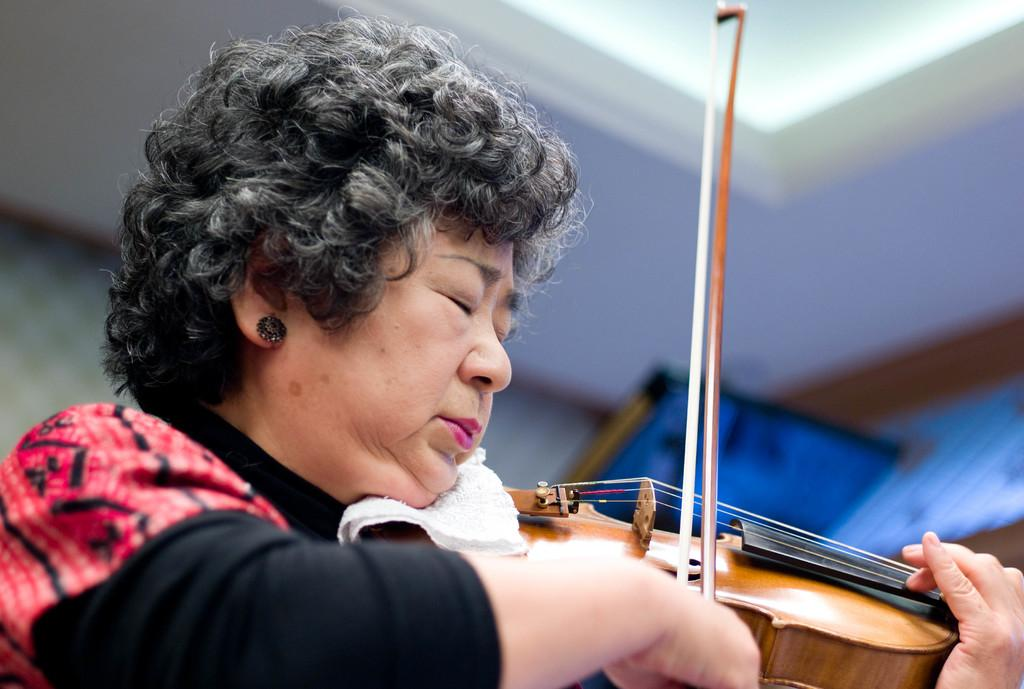Who is the main subject in the image? There is a woman in the image. What is the woman doing in the image? The woman is playing the violin. Can you describe the woman's facial expression in the image? The woman is closing her eyes in the image. What is the woman's opinion on the station in the image? There is no station present in the image, and therefore no opinion can be determined. 